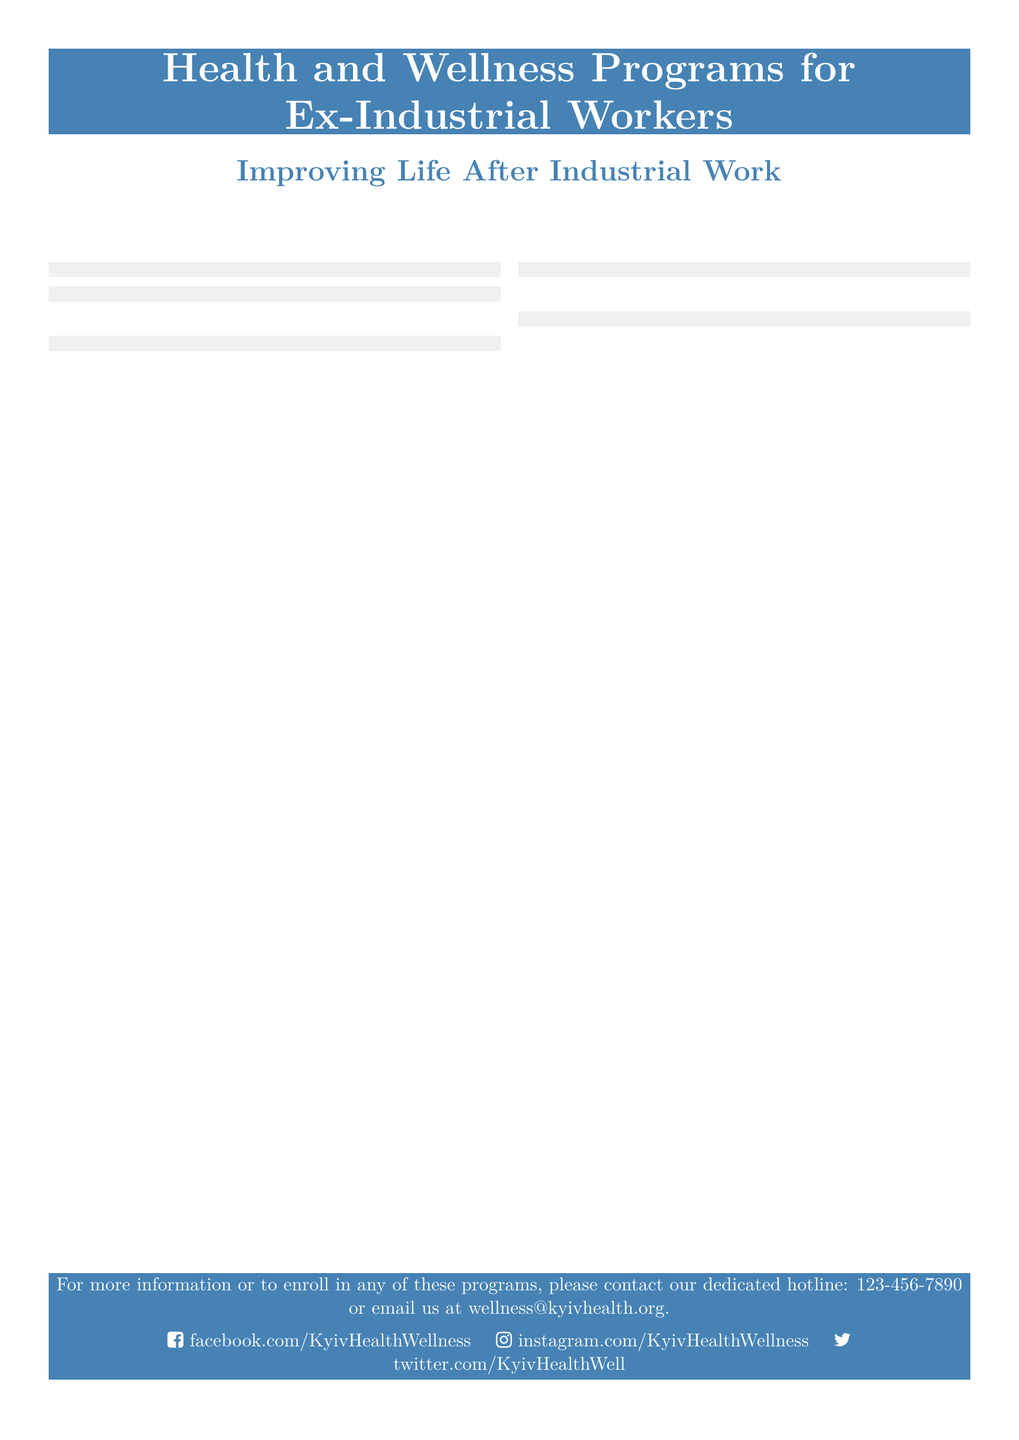What is the first program mentioned? The first program listed in the document is "Comprehensive Health Check-ups."
Answer: Comprehensive Health Check-ups How many programs are described in the flyer? There are five programs detailed in the document for ex-industrial workers.
Answer: 5 What type of therapy is provided in the Mental Health Support program? The Mental Health Support program includes cognitive-behavioral therapy as one of its services.
Answer: cognitive-behavioral therapy What organization conducts specialized screenings for occupational diseases? The Ukrainian Institute of Occupational Health is responsible for conducting these screenings.
Answer: Ukrainian Institute of Occupational Health What support does the Rehabilitation Clinic of Kyiv offer? The Rehabilitation Clinic of Kyiv offers tailored physical therapy programs.
Answer: tailored physical therapy programs What is emphasized as essential for maintaining overall wellness? The document emphasizes adopting a healthy diet as essential for maintaining overall wellness.
Answer: a healthy diet Is there a contact number provided for more information? Yes, the flyer includes a dedicated hotline number for inquiries about the programs.
Answer: 123-456-7890 What is the primary focus of the Nutritional Guidance program? The Nutritional Guidance program focuses on personalized dietary plans.
Answer: personalized dietary plans 